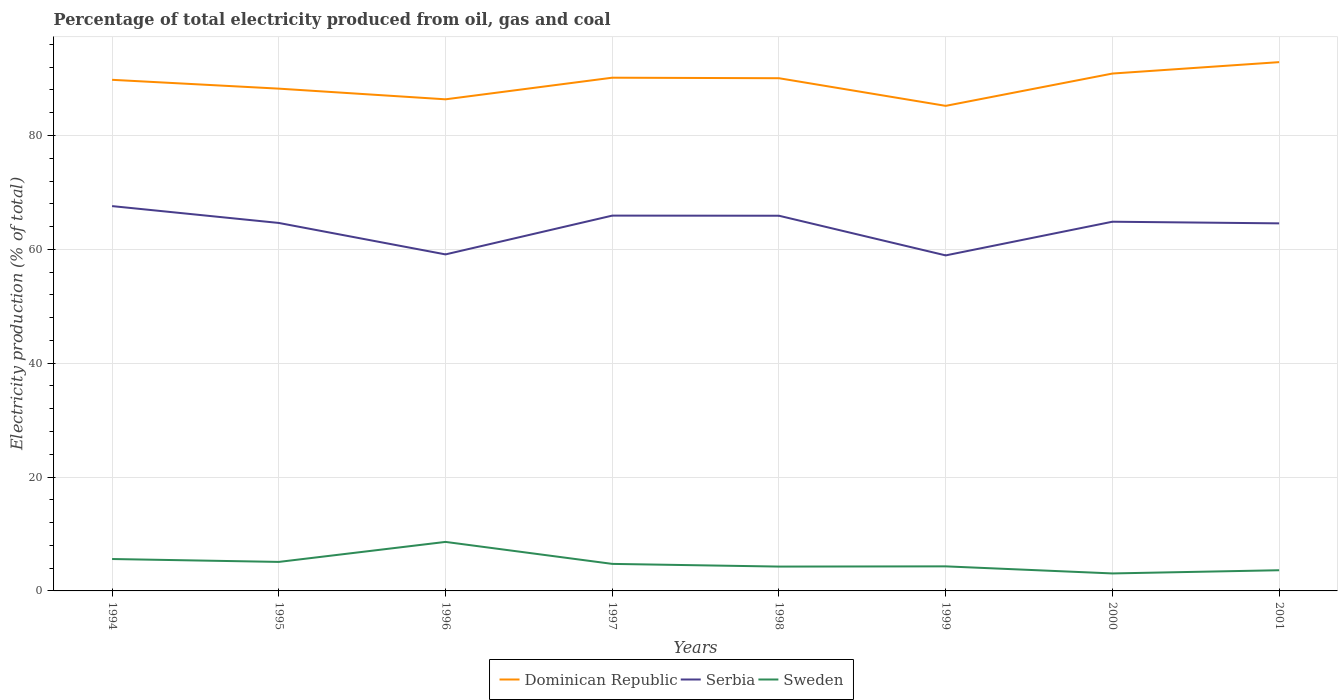How many different coloured lines are there?
Your answer should be very brief. 3. Does the line corresponding to Sweden intersect with the line corresponding to Serbia?
Make the answer very short. No. Across all years, what is the maximum electricity production in in Dominican Republic?
Ensure brevity in your answer.  85.2. What is the total electricity production in in Serbia in the graph?
Provide a succinct answer. -5.92. What is the difference between the highest and the second highest electricity production in in Dominican Republic?
Your answer should be compact. 7.68. What is the difference between the highest and the lowest electricity production in in Sweden?
Provide a succinct answer. 3. Is the electricity production in in Dominican Republic strictly greater than the electricity production in in Serbia over the years?
Make the answer very short. No. How many years are there in the graph?
Keep it short and to the point. 8. What is the difference between two consecutive major ticks on the Y-axis?
Offer a very short reply. 20. Does the graph contain any zero values?
Ensure brevity in your answer.  No. Does the graph contain grids?
Make the answer very short. Yes. How are the legend labels stacked?
Offer a very short reply. Horizontal. What is the title of the graph?
Your response must be concise. Percentage of total electricity produced from oil, gas and coal. What is the label or title of the Y-axis?
Give a very brief answer. Electricity production (% of total). What is the Electricity production (% of total) in Dominican Republic in 1994?
Ensure brevity in your answer.  89.78. What is the Electricity production (% of total) in Serbia in 1994?
Provide a short and direct response. 67.59. What is the Electricity production (% of total) in Sweden in 1994?
Give a very brief answer. 5.6. What is the Electricity production (% of total) of Dominican Republic in 1995?
Provide a short and direct response. 88.22. What is the Electricity production (% of total) in Serbia in 1995?
Your answer should be very brief. 64.63. What is the Electricity production (% of total) of Sweden in 1995?
Provide a short and direct response. 5.1. What is the Electricity production (% of total) of Dominican Republic in 1996?
Your answer should be compact. 86.35. What is the Electricity production (% of total) in Serbia in 1996?
Offer a very short reply. 59.11. What is the Electricity production (% of total) in Sweden in 1996?
Give a very brief answer. 8.61. What is the Electricity production (% of total) in Dominican Republic in 1997?
Offer a terse response. 90.15. What is the Electricity production (% of total) of Serbia in 1997?
Your answer should be compact. 65.92. What is the Electricity production (% of total) in Sweden in 1997?
Offer a terse response. 4.75. What is the Electricity production (% of total) in Dominican Republic in 1998?
Your answer should be very brief. 90.06. What is the Electricity production (% of total) of Serbia in 1998?
Make the answer very short. 65.9. What is the Electricity production (% of total) in Sweden in 1998?
Offer a terse response. 4.27. What is the Electricity production (% of total) in Dominican Republic in 1999?
Offer a very short reply. 85.2. What is the Electricity production (% of total) of Serbia in 1999?
Your answer should be compact. 58.93. What is the Electricity production (% of total) in Sweden in 1999?
Your answer should be very brief. 4.31. What is the Electricity production (% of total) in Dominican Republic in 2000?
Ensure brevity in your answer.  90.88. What is the Electricity production (% of total) of Serbia in 2000?
Offer a very short reply. 64.85. What is the Electricity production (% of total) in Sweden in 2000?
Make the answer very short. 3.07. What is the Electricity production (% of total) in Dominican Republic in 2001?
Provide a succinct answer. 92.88. What is the Electricity production (% of total) of Serbia in 2001?
Make the answer very short. 64.56. What is the Electricity production (% of total) in Sweden in 2001?
Provide a succinct answer. 3.63. Across all years, what is the maximum Electricity production (% of total) of Dominican Republic?
Give a very brief answer. 92.88. Across all years, what is the maximum Electricity production (% of total) of Serbia?
Keep it short and to the point. 67.59. Across all years, what is the maximum Electricity production (% of total) of Sweden?
Provide a short and direct response. 8.61. Across all years, what is the minimum Electricity production (% of total) in Dominican Republic?
Give a very brief answer. 85.2. Across all years, what is the minimum Electricity production (% of total) of Serbia?
Offer a terse response. 58.93. Across all years, what is the minimum Electricity production (% of total) of Sweden?
Your answer should be very brief. 3.07. What is the total Electricity production (% of total) of Dominican Republic in the graph?
Your answer should be compact. 713.51. What is the total Electricity production (% of total) in Serbia in the graph?
Provide a succinct answer. 511.5. What is the total Electricity production (% of total) in Sweden in the graph?
Provide a short and direct response. 39.35. What is the difference between the Electricity production (% of total) of Dominican Republic in 1994 and that in 1995?
Your answer should be very brief. 1.55. What is the difference between the Electricity production (% of total) in Serbia in 1994 and that in 1995?
Your answer should be very brief. 2.96. What is the difference between the Electricity production (% of total) of Sweden in 1994 and that in 1995?
Your response must be concise. 0.51. What is the difference between the Electricity production (% of total) in Dominican Republic in 1994 and that in 1996?
Your response must be concise. 3.43. What is the difference between the Electricity production (% of total) in Serbia in 1994 and that in 1996?
Your answer should be very brief. 8.48. What is the difference between the Electricity production (% of total) in Sweden in 1994 and that in 1996?
Your answer should be compact. -3.01. What is the difference between the Electricity production (% of total) in Dominican Republic in 1994 and that in 1997?
Make the answer very short. -0.37. What is the difference between the Electricity production (% of total) in Serbia in 1994 and that in 1997?
Offer a very short reply. 1.67. What is the difference between the Electricity production (% of total) of Sweden in 1994 and that in 1997?
Ensure brevity in your answer.  0.86. What is the difference between the Electricity production (% of total) in Dominican Republic in 1994 and that in 1998?
Ensure brevity in your answer.  -0.28. What is the difference between the Electricity production (% of total) of Serbia in 1994 and that in 1998?
Your response must be concise. 1.69. What is the difference between the Electricity production (% of total) in Sweden in 1994 and that in 1998?
Give a very brief answer. 1.33. What is the difference between the Electricity production (% of total) in Dominican Republic in 1994 and that in 1999?
Your answer should be very brief. 4.57. What is the difference between the Electricity production (% of total) of Serbia in 1994 and that in 1999?
Offer a terse response. 8.66. What is the difference between the Electricity production (% of total) in Sweden in 1994 and that in 1999?
Offer a very short reply. 1.29. What is the difference between the Electricity production (% of total) in Dominican Republic in 1994 and that in 2000?
Give a very brief answer. -1.1. What is the difference between the Electricity production (% of total) of Serbia in 1994 and that in 2000?
Offer a very short reply. 2.74. What is the difference between the Electricity production (% of total) in Sweden in 1994 and that in 2000?
Make the answer very short. 2.53. What is the difference between the Electricity production (% of total) in Dominican Republic in 1994 and that in 2001?
Offer a terse response. -3.1. What is the difference between the Electricity production (% of total) in Serbia in 1994 and that in 2001?
Keep it short and to the point. 3.03. What is the difference between the Electricity production (% of total) in Sweden in 1994 and that in 2001?
Offer a very short reply. 1.97. What is the difference between the Electricity production (% of total) of Dominican Republic in 1995 and that in 1996?
Keep it short and to the point. 1.87. What is the difference between the Electricity production (% of total) of Serbia in 1995 and that in 1996?
Offer a very short reply. 5.53. What is the difference between the Electricity production (% of total) in Sweden in 1995 and that in 1996?
Your answer should be compact. -3.51. What is the difference between the Electricity production (% of total) in Dominican Republic in 1995 and that in 1997?
Your answer should be compact. -1.92. What is the difference between the Electricity production (% of total) of Serbia in 1995 and that in 1997?
Give a very brief answer. -1.29. What is the difference between the Electricity production (% of total) in Sweden in 1995 and that in 1997?
Ensure brevity in your answer.  0.35. What is the difference between the Electricity production (% of total) of Dominican Republic in 1995 and that in 1998?
Provide a short and direct response. -1.83. What is the difference between the Electricity production (% of total) of Serbia in 1995 and that in 1998?
Your answer should be compact. -1.27. What is the difference between the Electricity production (% of total) in Sweden in 1995 and that in 1998?
Provide a short and direct response. 0.82. What is the difference between the Electricity production (% of total) of Dominican Republic in 1995 and that in 1999?
Offer a very short reply. 3.02. What is the difference between the Electricity production (% of total) of Serbia in 1995 and that in 1999?
Offer a very short reply. 5.7. What is the difference between the Electricity production (% of total) of Sweden in 1995 and that in 1999?
Offer a very short reply. 0.78. What is the difference between the Electricity production (% of total) in Dominican Republic in 1995 and that in 2000?
Your answer should be very brief. -2.65. What is the difference between the Electricity production (% of total) of Serbia in 1995 and that in 2000?
Offer a terse response. -0.22. What is the difference between the Electricity production (% of total) of Sweden in 1995 and that in 2000?
Ensure brevity in your answer.  2.02. What is the difference between the Electricity production (% of total) in Dominican Republic in 1995 and that in 2001?
Ensure brevity in your answer.  -4.66. What is the difference between the Electricity production (% of total) of Serbia in 1995 and that in 2001?
Offer a very short reply. 0.07. What is the difference between the Electricity production (% of total) in Sweden in 1995 and that in 2001?
Offer a very short reply. 1.46. What is the difference between the Electricity production (% of total) in Dominican Republic in 1996 and that in 1997?
Keep it short and to the point. -3.8. What is the difference between the Electricity production (% of total) of Serbia in 1996 and that in 1997?
Make the answer very short. -6.81. What is the difference between the Electricity production (% of total) in Sweden in 1996 and that in 1997?
Provide a succinct answer. 3.86. What is the difference between the Electricity production (% of total) in Dominican Republic in 1996 and that in 1998?
Your answer should be compact. -3.71. What is the difference between the Electricity production (% of total) of Serbia in 1996 and that in 1998?
Provide a succinct answer. -6.79. What is the difference between the Electricity production (% of total) of Sweden in 1996 and that in 1998?
Your response must be concise. 4.33. What is the difference between the Electricity production (% of total) of Dominican Republic in 1996 and that in 1999?
Make the answer very short. 1.15. What is the difference between the Electricity production (% of total) of Serbia in 1996 and that in 1999?
Keep it short and to the point. 0.17. What is the difference between the Electricity production (% of total) in Sweden in 1996 and that in 1999?
Ensure brevity in your answer.  4.3. What is the difference between the Electricity production (% of total) in Dominican Republic in 1996 and that in 2000?
Make the answer very short. -4.53. What is the difference between the Electricity production (% of total) of Serbia in 1996 and that in 2000?
Your answer should be compact. -5.74. What is the difference between the Electricity production (% of total) in Sweden in 1996 and that in 2000?
Offer a terse response. 5.54. What is the difference between the Electricity production (% of total) in Dominican Republic in 1996 and that in 2001?
Provide a short and direct response. -6.53. What is the difference between the Electricity production (% of total) in Serbia in 1996 and that in 2001?
Give a very brief answer. -5.45. What is the difference between the Electricity production (% of total) of Sweden in 1996 and that in 2001?
Ensure brevity in your answer.  4.98. What is the difference between the Electricity production (% of total) of Dominican Republic in 1997 and that in 1998?
Give a very brief answer. 0.09. What is the difference between the Electricity production (% of total) in Serbia in 1997 and that in 1998?
Provide a short and direct response. 0.02. What is the difference between the Electricity production (% of total) in Sweden in 1997 and that in 1998?
Offer a terse response. 0.47. What is the difference between the Electricity production (% of total) of Dominican Republic in 1997 and that in 1999?
Give a very brief answer. 4.95. What is the difference between the Electricity production (% of total) of Serbia in 1997 and that in 1999?
Your answer should be very brief. 6.99. What is the difference between the Electricity production (% of total) of Sweden in 1997 and that in 1999?
Your answer should be very brief. 0.43. What is the difference between the Electricity production (% of total) in Dominican Republic in 1997 and that in 2000?
Your answer should be compact. -0.73. What is the difference between the Electricity production (% of total) of Serbia in 1997 and that in 2000?
Make the answer very short. 1.07. What is the difference between the Electricity production (% of total) in Sweden in 1997 and that in 2000?
Give a very brief answer. 1.68. What is the difference between the Electricity production (% of total) in Dominican Republic in 1997 and that in 2001?
Your response must be concise. -2.73. What is the difference between the Electricity production (% of total) of Serbia in 1997 and that in 2001?
Keep it short and to the point. 1.36. What is the difference between the Electricity production (% of total) in Sweden in 1997 and that in 2001?
Your answer should be very brief. 1.12. What is the difference between the Electricity production (% of total) of Dominican Republic in 1998 and that in 1999?
Your answer should be very brief. 4.86. What is the difference between the Electricity production (% of total) in Serbia in 1998 and that in 1999?
Offer a very short reply. 6.97. What is the difference between the Electricity production (% of total) in Sweden in 1998 and that in 1999?
Provide a succinct answer. -0.04. What is the difference between the Electricity production (% of total) of Dominican Republic in 1998 and that in 2000?
Ensure brevity in your answer.  -0.82. What is the difference between the Electricity production (% of total) in Serbia in 1998 and that in 2000?
Provide a succinct answer. 1.05. What is the difference between the Electricity production (% of total) in Sweden in 1998 and that in 2000?
Your response must be concise. 1.2. What is the difference between the Electricity production (% of total) of Dominican Republic in 1998 and that in 2001?
Provide a succinct answer. -2.82. What is the difference between the Electricity production (% of total) in Serbia in 1998 and that in 2001?
Your answer should be very brief. 1.34. What is the difference between the Electricity production (% of total) of Sweden in 1998 and that in 2001?
Make the answer very short. 0.64. What is the difference between the Electricity production (% of total) in Dominican Republic in 1999 and that in 2000?
Offer a very short reply. -5.68. What is the difference between the Electricity production (% of total) of Serbia in 1999 and that in 2000?
Provide a short and direct response. -5.92. What is the difference between the Electricity production (% of total) of Sweden in 1999 and that in 2000?
Ensure brevity in your answer.  1.24. What is the difference between the Electricity production (% of total) in Dominican Republic in 1999 and that in 2001?
Make the answer very short. -7.68. What is the difference between the Electricity production (% of total) in Serbia in 1999 and that in 2001?
Provide a short and direct response. -5.63. What is the difference between the Electricity production (% of total) of Sweden in 1999 and that in 2001?
Provide a succinct answer. 0.68. What is the difference between the Electricity production (% of total) in Dominican Republic in 2000 and that in 2001?
Your answer should be very brief. -2. What is the difference between the Electricity production (% of total) in Serbia in 2000 and that in 2001?
Offer a very short reply. 0.29. What is the difference between the Electricity production (% of total) in Sweden in 2000 and that in 2001?
Your answer should be very brief. -0.56. What is the difference between the Electricity production (% of total) of Dominican Republic in 1994 and the Electricity production (% of total) of Serbia in 1995?
Provide a short and direct response. 25.14. What is the difference between the Electricity production (% of total) of Dominican Republic in 1994 and the Electricity production (% of total) of Sweden in 1995?
Provide a short and direct response. 84.68. What is the difference between the Electricity production (% of total) of Serbia in 1994 and the Electricity production (% of total) of Sweden in 1995?
Provide a succinct answer. 62.5. What is the difference between the Electricity production (% of total) of Dominican Republic in 1994 and the Electricity production (% of total) of Serbia in 1996?
Keep it short and to the point. 30.67. What is the difference between the Electricity production (% of total) of Dominican Republic in 1994 and the Electricity production (% of total) of Sweden in 1996?
Keep it short and to the point. 81.17. What is the difference between the Electricity production (% of total) in Serbia in 1994 and the Electricity production (% of total) in Sweden in 1996?
Make the answer very short. 58.98. What is the difference between the Electricity production (% of total) in Dominican Republic in 1994 and the Electricity production (% of total) in Serbia in 1997?
Make the answer very short. 23.85. What is the difference between the Electricity production (% of total) of Dominican Republic in 1994 and the Electricity production (% of total) of Sweden in 1997?
Your response must be concise. 85.03. What is the difference between the Electricity production (% of total) of Serbia in 1994 and the Electricity production (% of total) of Sweden in 1997?
Give a very brief answer. 62.84. What is the difference between the Electricity production (% of total) of Dominican Republic in 1994 and the Electricity production (% of total) of Serbia in 1998?
Give a very brief answer. 23.87. What is the difference between the Electricity production (% of total) in Dominican Republic in 1994 and the Electricity production (% of total) in Sweden in 1998?
Make the answer very short. 85.5. What is the difference between the Electricity production (% of total) in Serbia in 1994 and the Electricity production (% of total) in Sweden in 1998?
Your response must be concise. 63.32. What is the difference between the Electricity production (% of total) in Dominican Republic in 1994 and the Electricity production (% of total) in Serbia in 1999?
Offer a very short reply. 30.84. What is the difference between the Electricity production (% of total) in Dominican Republic in 1994 and the Electricity production (% of total) in Sweden in 1999?
Your answer should be very brief. 85.46. What is the difference between the Electricity production (% of total) in Serbia in 1994 and the Electricity production (% of total) in Sweden in 1999?
Keep it short and to the point. 63.28. What is the difference between the Electricity production (% of total) in Dominican Republic in 1994 and the Electricity production (% of total) in Serbia in 2000?
Your response must be concise. 24.92. What is the difference between the Electricity production (% of total) in Dominican Republic in 1994 and the Electricity production (% of total) in Sweden in 2000?
Make the answer very short. 86.7. What is the difference between the Electricity production (% of total) in Serbia in 1994 and the Electricity production (% of total) in Sweden in 2000?
Offer a very short reply. 64.52. What is the difference between the Electricity production (% of total) in Dominican Republic in 1994 and the Electricity production (% of total) in Serbia in 2001?
Provide a succinct answer. 25.22. What is the difference between the Electricity production (% of total) in Dominican Republic in 1994 and the Electricity production (% of total) in Sweden in 2001?
Make the answer very short. 86.14. What is the difference between the Electricity production (% of total) in Serbia in 1994 and the Electricity production (% of total) in Sweden in 2001?
Provide a succinct answer. 63.96. What is the difference between the Electricity production (% of total) of Dominican Republic in 1995 and the Electricity production (% of total) of Serbia in 1996?
Your answer should be very brief. 29.12. What is the difference between the Electricity production (% of total) in Dominican Republic in 1995 and the Electricity production (% of total) in Sweden in 1996?
Ensure brevity in your answer.  79.61. What is the difference between the Electricity production (% of total) of Serbia in 1995 and the Electricity production (% of total) of Sweden in 1996?
Offer a very short reply. 56.02. What is the difference between the Electricity production (% of total) in Dominican Republic in 1995 and the Electricity production (% of total) in Serbia in 1997?
Ensure brevity in your answer.  22.3. What is the difference between the Electricity production (% of total) in Dominican Republic in 1995 and the Electricity production (% of total) in Sweden in 1997?
Ensure brevity in your answer.  83.47. What is the difference between the Electricity production (% of total) of Serbia in 1995 and the Electricity production (% of total) of Sweden in 1997?
Your response must be concise. 59.88. What is the difference between the Electricity production (% of total) of Dominican Republic in 1995 and the Electricity production (% of total) of Serbia in 1998?
Your response must be concise. 22.32. What is the difference between the Electricity production (% of total) of Dominican Republic in 1995 and the Electricity production (% of total) of Sweden in 1998?
Your answer should be compact. 83.95. What is the difference between the Electricity production (% of total) of Serbia in 1995 and the Electricity production (% of total) of Sweden in 1998?
Give a very brief answer. 60.36. What is the difference between the Electricity production (% of total) in Dominican Republic in 1995 and the Electricity production (% of total) in Serbia in 1999?
Offer a terse response. 29.29. What is the difference between the Electricity production (% of total) in Dominican Republic in 1995 and the Electricity production (% of total) in Sweden in 1999?
Make the answer very short. 83.91. What is the difference between the Electricity production (% of total) of Serbia in 1995 and the Electricity production (% of total) of Sweden in 1999?
Ensure brevity in your answer.  60.32. What is the difference between the Electricity production (% of total) of Dominican Republic in 1995 and the Electricity production (% of total) of Serbia in 2000?
Your answer should be very brief. 23.37. What is the difference between the Electricity production (% of total) in Dominican Republic in 1995 and the Electricity production (% of total) in Sweden in 2000?
Provide a succinct answer. 85.15. What is the difference between the Electricity production (% of total) of Serbia in 1995 and the Electricity production (% of total) of Sweden in 2000?
Your answer should be very brief. 61.56. What is the difference between the Electricity production (% of total) in Dominican Republic in 1995 and the Electricity production (% of total) in Serbia in 2001?
Your answer should be very brief. 23.66. What is the difference between the Electricity production (% of total) in Dominican Republic in 1995 and the Electricity production (% of total) in Sweden in 2001?
Offer a very short reply. 84.59. What is the difference between the Electricity production (% of total) in Serbia in 1995 and the Electricity production (% of total) in Sweden in 2001?
Keep it short and to the point. 61. What is the difference between the Electricity production (% of total) in Dominican Republic in 1996 and the Electricity production (% of total) in Serbia in 1997?
Provide a succinct answer. 20.43. What is the difference between the Electricity production (% of total) in Dominican Republic in 1996 and the Electricity production (% of total) in Sweden in 1997?
Your answer should be compact. 81.6. What is the difference between the Electricity production (% of total) of Serbia in 1996 and the Electricity production (% of total) of Sweden in 1997?
Your answer should be compact. 54.36. What is the difference between the Electricity production (% of total) in Dominican Republic in 1996 and the Electricity production (% of total) in Serbia in 1998?
Provide a succinct answer. 20.45. What is the difference between the Electricity production (% of total) in Dominican Republic in 1996 and the Electricity production (% of total) in Sweden in 1998?
Provide a short and direct response. 82.07. What is the difference between the Electricity production (% of total) in Serbia in 1996 and the Electricity production (% of total) in Sweden in 1998?
Keep it short and to the point. 54.83. What is the difference between the Electricity production (% of total) in Dominican Republic in 1996 and the Electricity production (% of total) in Serbia in 1999?
Ensure brevity in your answer.  27.41. What is the difference between the Electricity production (% of total) in Dominican Republic in 1996 and the Electricity production (% of total) in Sweden in 1999?
Ensure brevity in your answer.  82.03. What is the difference between the Electricity production (% of total) of Serbia in 1996 and the Electricity production (% of total) of Sweden in 1999?
Offer a very short reply. 54.79. What is the difference between the Electricity production (% of total) of Dominican Republic in 1996 and the Electricity production (% of total) of Serbia in 2000?
Give a very brief answer. 21.5. What is the difference between the Electricity production (% of total) in Dominican Republic in 1996 and the Electricity production (% of total) in Sweden in 2000?
Ensure brevity in your answer.  83.28. What is the difference between the Electricity production (% of total) of Serbia in 1996 and the Electricity production (% of total) of Sweden in 2000?
Provide a short and direct response. 56.04. What is the difference between the Electricity production (% of total) of Dominican Republic in 1996 and the Electricity production (% of total) of Serbia in 2001?
Offer a very short reply. 21.79. What is the difference between the Electricity production (% of total) in Dominican Republic in 1996 and the Electricity production (% of total) in Sweden in 2001?
Offer a very short reply. 82.72. What is the difference between the Electricity production (% of total) of Serbia in 1996 and the Electricity production (% of total) of Sweden in 2001?
Keep it short and to the point. 55.48. What is the difference between the Electricity production (% of total) of Dominican Republic in 1997 and the Electricity production (% of total) of Serbia in 1998?
Offer a very short reply. 24.25. What is the difference between the Electricity production (% of total) of Dominican Republic in 1997 and the Electricity production (% of total) of Sweden in 1998?
Provide a succinct answer. 85.87. What is the difference between the Electricity production (% of total) of Serbia in 1997 and the Electricity production (% of total) of Sweden in 1998?
Provide a short and direct response. 61.65. What is the difference between the Electricity production (% of total) of Dominican Republic in 1997 and the Electricity production (% of total) of Serbia in 1999?
Offer a terse response. 31.21. What is the difference between the Electricity production (% of total) in Dominican Republic in 1997 and the Electricity production (% of total) in Sweden in 1999?
Provide a short and direct response. 85.83. What is the difference between the Electricity production (% of total) of Serbia in 1997 and the Electricity production (% of total) of Sweden in 1999?
Make the answer very short. 61.61. What is the difference between the Electricity production (% of total) in Dominican Republic in 1997 and the Electricity production (% of total) in Serbia in 2000?
Provide a short and direct response. 25.3. What is the difference between the Electricity production (% of total) of Dominican Republic in 1997 and the Electricity production (% of total) of Sweden in 2000?
Keep it short and to the point. 87.07. What is the difference between the Electricity production (% of total) in Serbia in 1997 and the Electricity production (% of total) in Sweden in 2000?
Make the answer very short. 62.85. What is the difference between the Electricity production (% of total) of Dominican Republic in 1997 and the Electricity production (% of total) of Serbia in 2001?
Keep it short and to the point. 25.59. What is the difference between the Electricity production (% of total) in Dominican Republic in 1997 and the Electricity production (% of total) in Sweden in 2001?
Your response must be concise. 86.51. What is the difference between the Electricity production (% of total) of Serbia in 1997 and the Electricity production (% of total) of Sweden in 2001?
Offer a very short reply. 62.29. What is the difference between the Electricity production (% of total) of Dominican Republic in 1998 and the Electricity production (% of total) of Serbia in 1999?
Your response must be concise. 31.12. What is the difference between the Electricity production (% of total) of Dominican Republic in 1998 and the Electricity production (% of total) of Sweden in 1999?
Your response must be concise. 85.74. What is the difference between the Electricity production (% of total) in Serbia in 1998 and the Electricity production (% of total) in Sweden in 1999?
Give a very brief answer. 61.59. What is the difference between the Electricity production (% of total) in Dominican Republic in 1998 and the Electricity production (% of total) in Serbia in 2000?
Make the answer very short. 25.21. What is the difference between the Electricity production (% of total) of Dominican Republic in 1998 and the Electricity production (% of total) of Sweden in 2000?
Give a very brief answer. 86.98. What is the difference between the Electricity production (% of total) of Serbia in 1998 and the Electricity production (% of total) of Sweden in 2000?
Your response must be concise. 62.83. What is the difference between the Electricity production (% of total) in Dominican Republic in 1998 and the Electricity production (% of total) in Serbia in 2001?
Provide a succinct answer. 25.5. What is the difference between the Electricity production (% of total) of Dominican Republic in 1998 and the Electricity production (% of total) of Sweden in 2001?
Ensure brevity in your answer.  86.42. What is the difference between the Electricity production (% of total) of Serbia in 1998 and the Electricity production (% of total) of Sweden in 2001?
Keep it short and to the point. 62.27. What is the difference between the Electricity production (% of total) of Dominican Republic in 1999 and the Electricity production (% of total) of Serbia in 2000?
Give a very brief answer. 20.35. What is the difference between the Electricity production (% of total) of Dominican Republic in 1999 and the Electricity production (% of total) of Sweden in 2000?
Your answer should be very brief. 82.13. What is the difference between the Electricity production (% of total) of Serbia in 1999 and the Electricity production (% of total) of Sweden in 2000?
Your answer should be compact. 55.86. What is the difference between the Electricity production (% of total) in Dominican Republic in 1999 and the Electricity production (% of total) in Serbia in 2001?
Offer a very short reply. 20.64. What is the difference between the Electricity production (% of total) of Dominican Republic in 1999 and the Electricity production (% of total) of Sweden in 2001?
Offer a very short reply. 81.57. What is the difference between the Electricity production (% of total) in Serbia in 1999 and the Electricity production (% of total) in Sweden in 2001?
Your answer should be compact. 55.3. What is the difference between the Electricity production (% of total) in Dominican Republic in 2000 and the Electricity production (% of total) in Serbia in 2001?
Keep it short and to the point. 26.32. What is the difference between the Electricity production (% of total) of Dominican Republic in 2000 and the Electricity production (% of total) of Sweden in 2001?
Give a very brief answer. 87.24. What is the difference between the Electricity production (% of total) of Serbia in 2000 and the Electricity production (% of total) of Sweden in 2001?
Make the answer very short. 61.22. What is the average Electricity production (% of total) of Dominican Republic per year?
Provide a short and direct response. 89.19. What is the average Electricity production (% of total) in Serbia per year?
Your response must be concise. 63.94. What is the average Electricity production (% of total) of Sweden per year?
Ensure brevity in your answer.  4.92. In the year 1994, what is the difference between the Electricity production (% of total) of Dominican Republic and Electricity production (% of total) of Serbia?
Make the answer very short. 22.18. In the year 1994, what is the difference between the Electricity production (% of total) of Dominican Republic and Electricity production (% of total) of Sweden?
Provide a short and direct response. 84.17. In the year 1994, what is the difference between the Electricity production (% of total) of Serbia and Electricity production (% of total) of Sweden?
Make the answer very short. 61.99. In the year 1995, what is the difference between the Electricity production (% of total) of Dominican Republic and Electricity production (% of total) of Serbia?
Give a very brief answer. 23.59. In the year 1995, what is the difference between the Electricity production (% of total) of Dominican Republic and Electricity production (% of total) of Sweden?
Give a very brief answer. 83.13. In the year 1995, what is the difference between the Electricity production (% of total) in Serbia and Electricity production (% of total) in Sweden?
Provide a succinct answer. 59.54. In the year 1996, what is the difference between the Electricity production (% of total) of Dominican Republic and Electricity production (% of total) of Serbia?
Ensure brevity in your answer.  27.24. In the year 1996, what is the difference between the Electricity production (% of total) in Dominican Republic and Electricity production (% of total) in Sweden?
Make the answer very short. 77.74. In the year 1996, what is the difference between the Electricity production (% of total) of Serbia and Electricity production (% of total) of Sweden?
Offer a very short reply. 50.5. In the year 1997, what is the difference between the Electricity production (% of total) of Dominican Republic and Electricity production (% of total) of Serbia?
Provide a short and direct response. 24.22. In the year 1997, what is the difference between the Electricity production (% of total) of Dominican Republic and Electricity production (% of total) of Sweden?
Make the answer very short. 85.4. In the year 1997, what is the difference between the Electricity production (% of total) of Serbia and Electricity production (% of total) of Sweden?
Offer a terse response. 61.17. In the year 1998, what is the difference between the Electricity production (% of total) in Dominican Republic and Electricity production (% of total) in Serbia?
Provide a short and direct response. 24.15. In the year 1998, what is the difference between the Electricity production (% of total) of Dominican Republic and Electricity production (% of total) of Sweden?
Your answer should be very brief. 85.78. In the year 1998, what is the difference between the Electricity production (% of total) in Serbia and Electricity production (% of total) in Sweden?
Offer a terse response. 61.63. In the year 1999, what is the difference between the Electricity production (% of total) of Dominican Republic and Electricity production (% of total) of Serbia?
Offer a very short reply. 26.27. In the year 1999, what is the difference between the Electricity production (% of total) of Dominican Republic and Electricity production (% of total) of Sweden?
Keep it short and to the point. 80.89. In the year 1999, what is the difference between the Electricity production (% of total) of Serbia and Electricity production (% of total) of Sweden?
Keep it short and to the point. 54.62. In the year 2000, what is the difference between the Electricity production (% of total) in Dominican Republic and Electricity production (% of total) in Serbia?
Your answer should be very brief. 26.03. In the year 2000, what is the difference between the Electricity production (% of total) of Dominican Republic and Electricity production (% of total) of Sweden?
Your answer should be very brief. 87.8. In the year 2000, what is the difference between the Electricity production (% of total) in Serbia and Electricity production (% of total) in Sweden?
Offer a very short reply. 61.78. In the year 2001, what is the difference between the Electricity production (% of total) of Dominican Republic and Electricity production (% of total) of Serbia?
Offer a terse response. 28.32. In the year 2001, what is the difference between the Electricity production (% of total) in Dominican Republic and Electricity production (% of total) in Sweden?
Make the answer very short. 89.25. In the year 2001, what is the difference between the Electricity production (% of total) of Serbia and Electricity production (% of total) of Sweden?
Offer a very short reply. 60.93. What is the ratio of the Electricity production (% of total) of Dominican Republic in 1994 to that in 1995?
Your answer should be very brief. 1.02. What is the ratio of the Electricity production (% of total) of Serbia in 1994 to that in 1995?
Offer a very short reply. 1.05. What is the ratio of the Electricity production (% of total) of Sweden in 1994 to that in 1995?
Provide a short and direct response. 1.1. What is the ratio of the Electricity production (% of total) of Dominican Republic in 1994 to that in 1996?
Make the answer very short. 1.04. What is the ratio of the Electricity production (% of total) of Serbia in 1994 to that in 1996?
Provide a short and direct response. 1.14. What is the ratio of the Electricity production (% of total) in Sweden in 1994 to that in 1996?
Your response must be concise. 0.65. What is the ratio of the Electricity production (% of total) in Dominican Republic in 1994 to that in 1997?
Your answer should be very brief. 1. What is the ratio of the Electricity production (% of total) of Serbia in 1994 to that in 1997?
Your answer should be very brief. 1.03. What is the ratio of the Electricity production (% of total) in Sweden in 1994 to that in 1997?
Your response must be concise. 1.18. What is the ratio of the Electricity production (% of total) of Dominican Republic in 1994 to that in 1998?
Provide a short and direct response. 1. What is the ratio of the Electricity production (% of total) in Serbia in 1994 to that in 1998?
Your answer should be very brief. 1.03. What is the ratio of the Electricity production (% of total) of Sweden in 1994 to that in 1998?
Make the answer very short. 1.31. What is the ratio of the Electricity production (% of total) of Dominican Republic in 1994 to that in 1999?
Your answer should be compact. 1.05. What is the ratio of the Electricity production (% of total) of Serbia in 1994 to that in 1999?
Provide a short and direct response. 1.15. What is the ratio of the Electricity production (% of total) of Sweden in 1994 to that in 1999?
Make the answer very short. 1.3. What is the ratio of the Electricity production (% of total) of Dominican Republic in 1994 to that in 2000?
Give a very brief answer. 0.99. What is the ratio of the Electricity production (% of total) of Serbia in 1994 to that in 2000?
Provide a short and direct response. 1.04. What is the ratio of the Electricity production (% of total) of Sweden in 1994 to that in 2000?
Your answer should be very brief. 1.82. What is the ratio of the Electricity production (% of total) in Dominican Republic in 1994 to that in 2001?
Offer a terse response. 0.97. What is the ratio of the Electricity production (% of total) in Serbia in 1994 to that in 2001?
Offer a terse response. 1.05. What is the ratio of the Electricity production (% of total) of Sweden in 1994 to that in 2001?
Give a very brief answer. 1.54. What is the ratio of the Electricity production (% of total) of Dominican Republic in 1995 to that in 1996?
Provide a succinct answer. 1.02. What is the ratio of the Electricity production (% of total) of Serbia in 1995 to that in 1996?
Give a very brief answer. 1.09. What is the ratio of the Electricity production (% of total) of Sweden in 1995 to that in 1996?
Your answer should be very brief. 0.59. What is the ratio of the Electricity production (% of total) of Dominican Republic in 1995 to that in 1997?
Keep it short and to the point. 0.98. What is the ratio of the Electricity production (% of total) in Serbia in 1995 to that in 1997?
Give a very brief answer. 0.98. What is the ratio of the Electricity production (% of total) of Sweden in 1995 to that in 1997?
Provide a succinct answer. 1.07. What is the ratio of the Electricity production (% of total) in Dominican Republic in 1995 to that in 1998?
Provide a succinct answer. 0.98. What is the ratio of the Electricity production (% of total) of Serbia in 1995 to that in 1998?
Keep it short and to the point. 0.98. What is the ratio of the Electricity production (% of total) in Sweden in 1995 to that in 1998?
Provide a succinct answer. 1.19. What is the ratio of the Electricity production (% of total) of Dominican Republic in 1995 to that in 1999?
Make the answer very short. 1.04. What is the ratio of the Electricity production (% of total) in Serbia in 1995 to that in 1999?
Provide a short and direct response. 1.1. What is the ratio of the Electricity production (% of total) of Sweden in 1995 to that in 1999?
Make the answer very short. 1.18. What is the ratio of the Electricity production (% of total) in Dominican Republic in 1995 to that in 2000?
Give a very brief answer. 0.97. What is the ratio of the Electricity production (% of total) in Sweden in 1995 to that in 2000?
Offer a terse response. 1.66. What is the ratio of the Electricity production (% of total) of Dominican Republic in 1995 to that in 2001?
Provide a succinct answer. 0.95. What is the ratio of the Electricity production (% of total) in Serbia in 1995 to that in 2001?
Keep it short and to the point. 1. What is the ratio of the Electricity production (% of total) in Sweden in 1995 to that in 2001?
Provide a succinct answer. 1.4. What is the ratio of the Electricity production (% of total) in Dominican Republic in 1996 to that in 1997?
Your answer should be very brief. 0.96. What is the ratio of the Electricity production (% of total) of Serbia in 1996 to that in 1997?
Keep it short and to the point. 0.9. What is the ratio of the Electricity production (% of total) in Sweden in 1996 to that in 1997?
Provide a short and direct response. 1.81. What is the ratio of the Electricity production (% of total) of Dominican Republic in 1996 to that in 1998?
Offer a very short reply. 0.96. What is the ratio of the Electricity production (% of total) in Serbia in 1996 to that in 1998?
Provide a succinct answer. 0.9. What is the ratio of the Electricity production (% of total) in Sweden in 1996 to that in 1998?
Your response must be concise. 2.01. What is the ratio of the Electricity production (% of total) in Dominican Republic in 1996 to that in 1999?
Offer a terse response. 1.01. What is the ratio of the Electricity production (% of total) of Serbia in 1996 to that in 1999?
Offer a very short reply. 1. What is the ratio of the Electricity production (% of total) of Sweden in 1996 to that in 1999?
Your response must be concise. 2. What is the ratio of the Electricity production (% of total) in Dominican Republic in 1996 to that in 2000?
Keep it short and to the point. 0.95. What is the ratio of the Electricity production (% of total) in Serbia in 1996 to that in 2000?
Your answer should be compact. 0.91. What is the ratio of the Electricity production (% of total) in Sweden in 1996 to that in 2000?
Give a very brief answer. 2.8. What is the ratio of the Electricity production (% of total) in Dominican Republic in 1996 to that in 2001?
Keep it short and to the point. 0.93. What is the ratio of the Electricity production (% of total) in Serbia in 1996 to that in 2001?
Provide a succinct answer. 0.92. What is the ratio of the Electricity production (% of total) in Sweden in 1996 to that in 2001?
Offer a terse response. 2.37. What is the ratio of the Electricity production (% of total) of Sweden in 1997 to that in 1998?
Ensure brevity in your answer.  1.11. What is the ratio of the Electricity production (% of total) in Dominican Republic in 1997 to that in 1999?
Offer a very short reply. 1.06. What is the ratio of the Electricity production (% of total) of Serbia in 1997 to that in 1999?
Your response must be concise. 1.12. What is the ratio of the Electricity production (% of total) of Sweden in 1997 to that in 1999?
Your answer should be very brief. 1.1. What is the ratio of the Electricity production (% of total) in Serbia in 1997 to that in 2000?
Your answer should be very brief. 1.02. What is the ratio of the Electricity production (% of total) of Sweden in 1997 to that in 2000?
Your answer should be compact. 1.55. What is the ratio of the Electricity production (% of total) of Dominican Republic in 1997 to that in 2001?
Ensure brevity in your answer.  0.97. What is the ratio of the Electricity production (% of total) of Serbia in 1997 to that in 2001?
Keep it short and to the point. 1.02. What is the ratio of the Electricity production (% of total) in Sweden in 1997 to that in 2001?
Give a very brief answer. 1.31. What is the ratio of the Electricity production (% of total) in Dominican Republic in 1998 to that in 1999?
Make the answer very short. 1.06. What is the ratio of the Electricity production (% of total) in Serbia in 1998 to that in 1999?
Make the answer very short. 1.12. What is the ratio of the Electricity production (% of total) in Sweden in 1998 to that in 1999?
Offer a very short reply. 0.99. What is the ratio of the Electricity production (% of total) of Dominican Republic in 1998 to that in 2000?
Keep it short and to the point. 0.99. What is the ratio of the Electricity production (% of total) in Serbia in 1998 to that in 2000?
Offer a very short reply. 1.02. What is the ratio of the Electricity production (% of total) of Sweden in 1998 to that in 2000?
Make the answer very short. 1.39. What is the ratio of the Electricity production (% of total) in Dominican Republic in 1998 to that in 2001?
Make the answer very short. 0.97. What is the ratio of the Electricity production (% of total) of Serbia in 1998 to that in 2001?
Offer a very short reply. 1.02. What is the ratio of the Electricity production (% of total) of Sweden in 1998 to that in 2001?
Provide a short and direct response. 1.18. What is the ratio of the Electricity production (% of total) in Dominican Republic in 1999 to that in 2000?
Your response must be concise. 0.94. What is the ratio of the Electricity production (% of total) in Serbia in 1999 to that in 2000?
Offer a terse response. 0.91. What is the ratio of the Electricity production (% of total) of Sweden in 1999 to that in 2000?
Give a very brief answer. 1.4. What is the ratio of the Electricity production (% of total) in Dominican Republic in 1999 to that in 2001?
Provide a succinct answer. 0.92. What is the ratio of the Electricity production (% of total) of Serbia in 1999 to that in 2001?
Offer a very short reply. 0.91. What is the ratio of the Electricity production (% of total) in Sweden in 1999 to that in 2001?
Your response must be concise. 1.19. What is the ratio of the Electricity production (% of total) of Dominican Republic in 2000 to that in 2001?
Offer a very short reply. 0.98. What is the ratio of the Electricity production (% of total) in Sweden in 2000 to that in 2001?
Offer a very short reply. 0.85. What is the difference between the highest and the second highest Electricity production (% of total) of Dominican Republic?
Provide a succinct answer. 2. What is the difference between the highest and the second highest Electricity production (% of total) of Serbia?
Your response must be concise. 1.67. What is the difference between the highest and the second highest Electricity production (% of total) in Sweden?
Keep it short and to the point. 3.01. What is the difference between the highest and the lowest Electricity production (% of total) of Dominican Republic?
Provide a short and direct response. 7.68. What is the difference between the highest and the lowest Electricity production (% of total) in Serbia?
Your answer should be very brief. 8.66. What is the difference between the highest and the lowest Electricity production (% of total) in Sweden?
Ensure brevity in your answer.  5.54. 